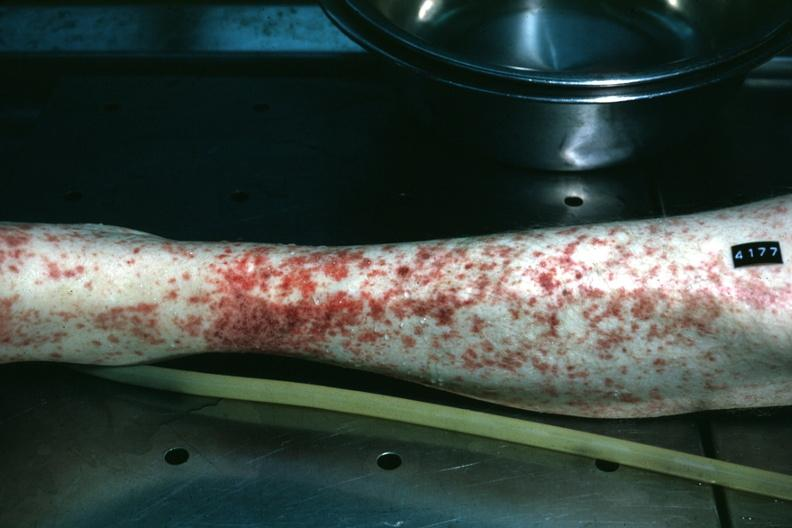s petechial and purpuric hemorrhages present?
Answer the question using a single word or phrase. Yes 